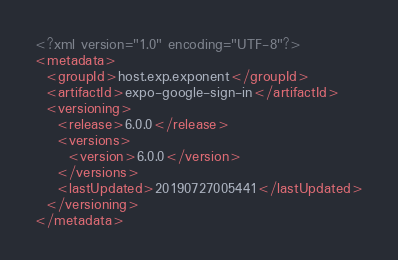Convert code to text. <code><loc_0><loc_0><loc_500><loc_500><_XML_><?xml version="1.0" encoding="UTF-8"?>
<metadata>
  <groupId>host.exp.exponent</groupId>
  <artifactId>expo-google-sign-in</artifactId>
  <versioning>
    <release>6.0.0</release>
    <versions>
      <version>6.0.0</version>
    </versions>
    <lastUpdated>20190727005441</lastUpdated>
  </versioning>
</metadata>
</code> 